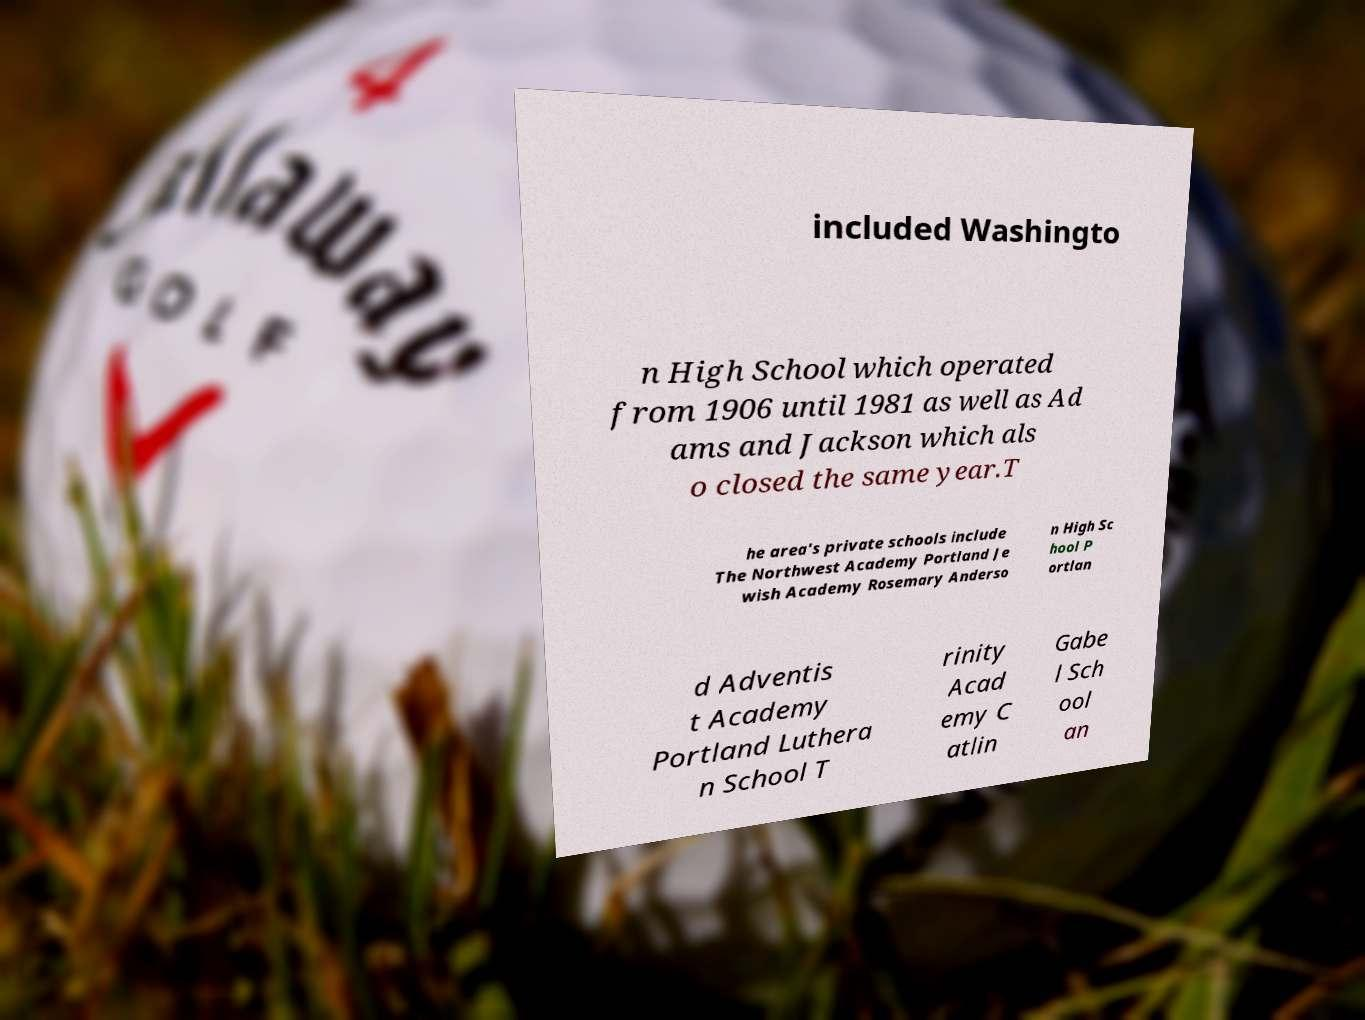Could you extract and type out the text from this image? included Washingto n High School which operated from 1906 until 1981 as well as Ad ams and Jackson which als o closed the same year.T he area's private schools include The Northwest Academy Portland Je wish Academy Rosemary Anderso n High Sc hool P ortlan d Adventis t Academy Portland Luthera n School T rinity Acad emy C atlin Gabe l Sch ool an 